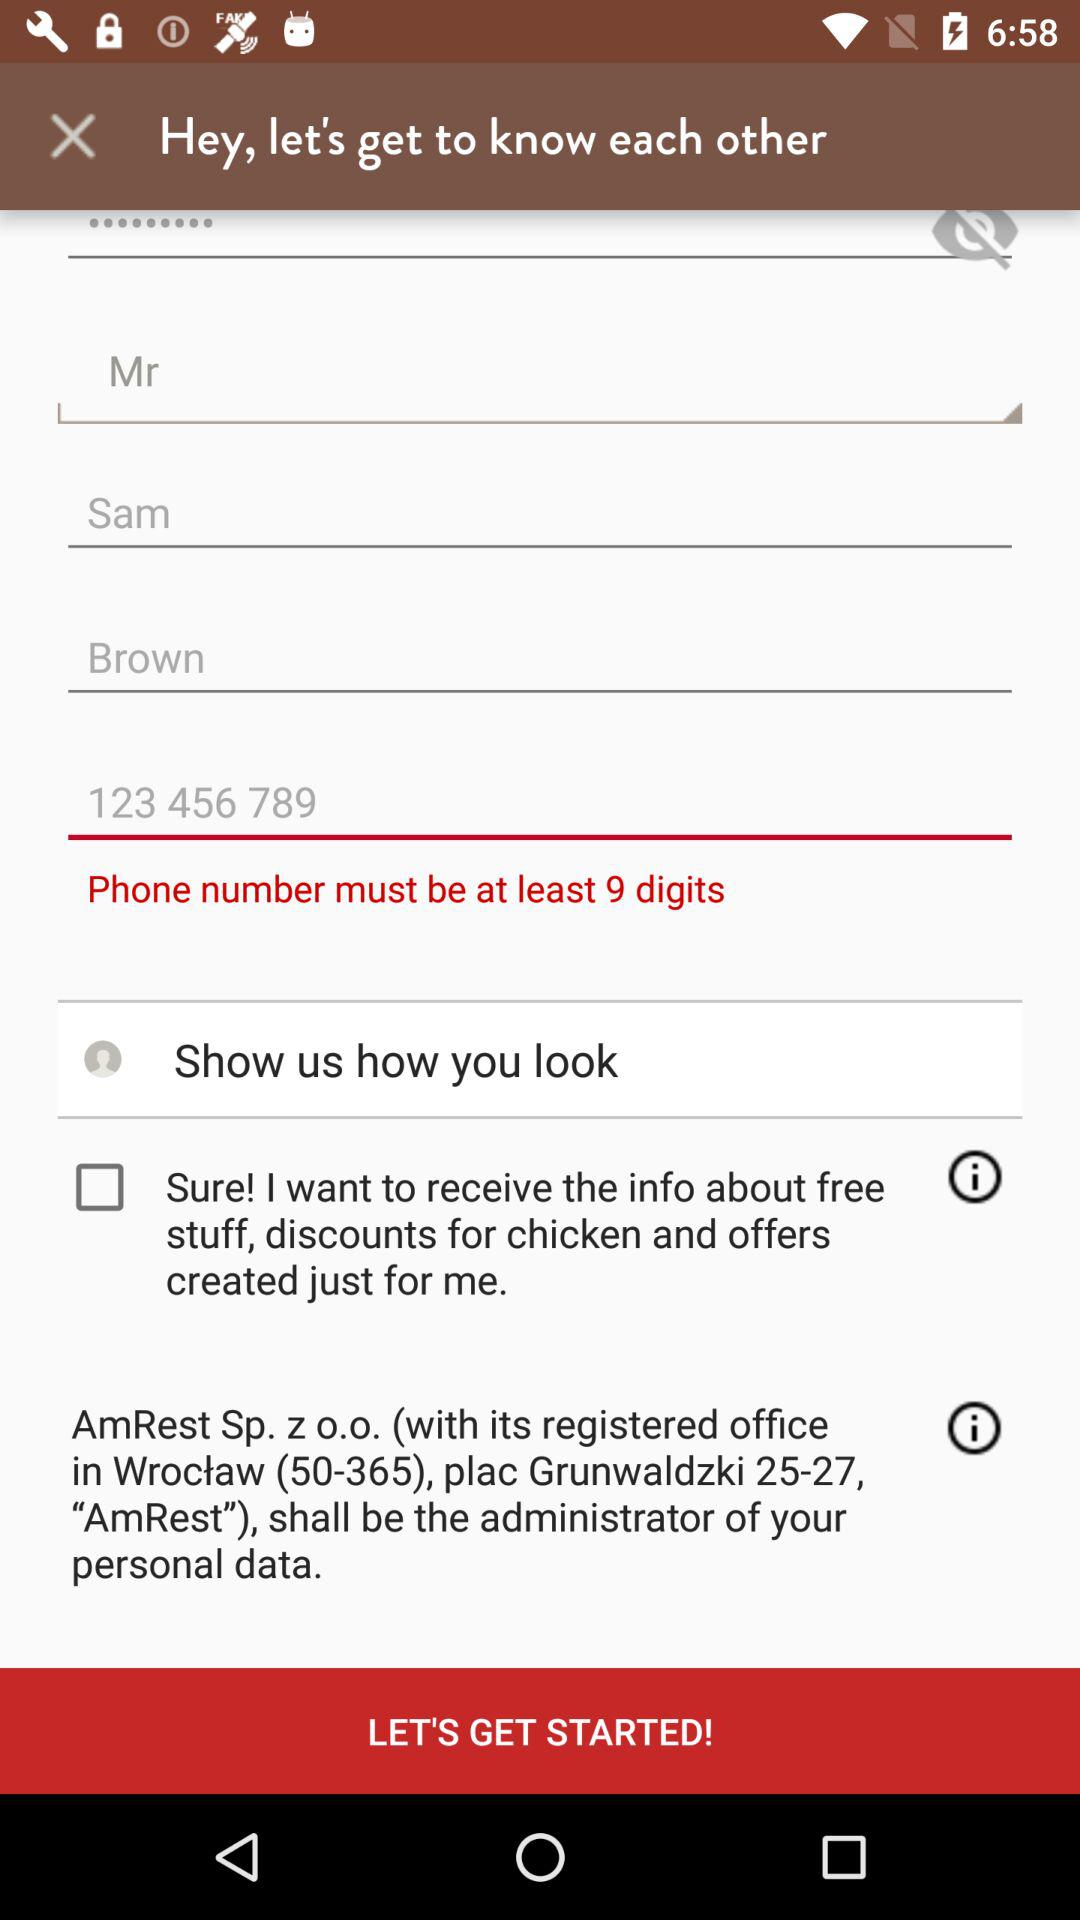What is the phone number? The phone number is 123 456 789. 